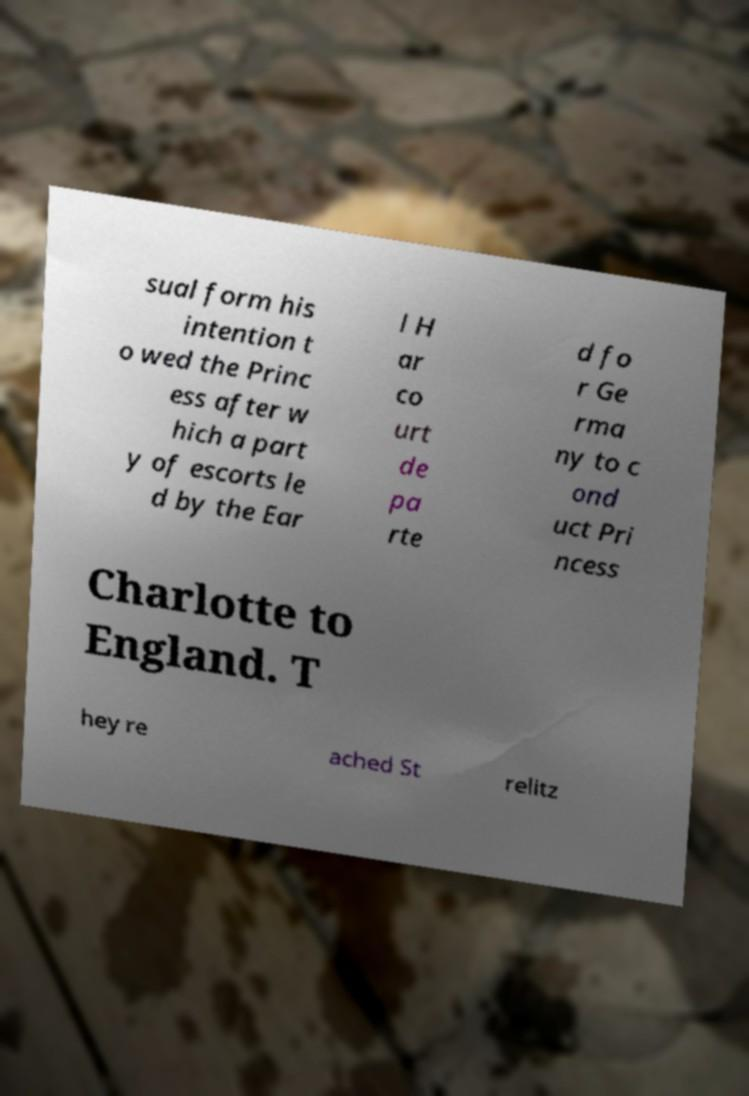Please read and relay the text visible in this image. What does it say? sual form his intention t o wed the Princ ess after w hich a part y of escorts le d by the Ear l H ar co urt de pa rte d fo r Ge rma ny to c ond uct Pri ncess Charlotte to England. T hey re ached St relitz 